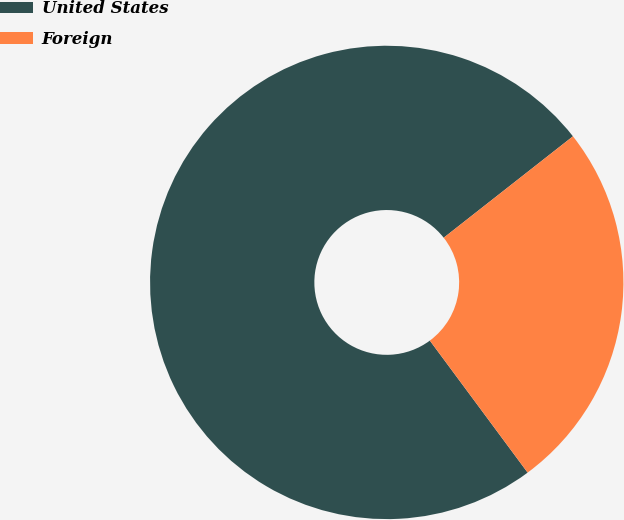<chart> <loc_0><loc_0><loc_500><loc_500><pie_chart><fcel>United States<fcel>Foreign<nl><fcel>74.56%<fcel>25.44%<nl></chart> 